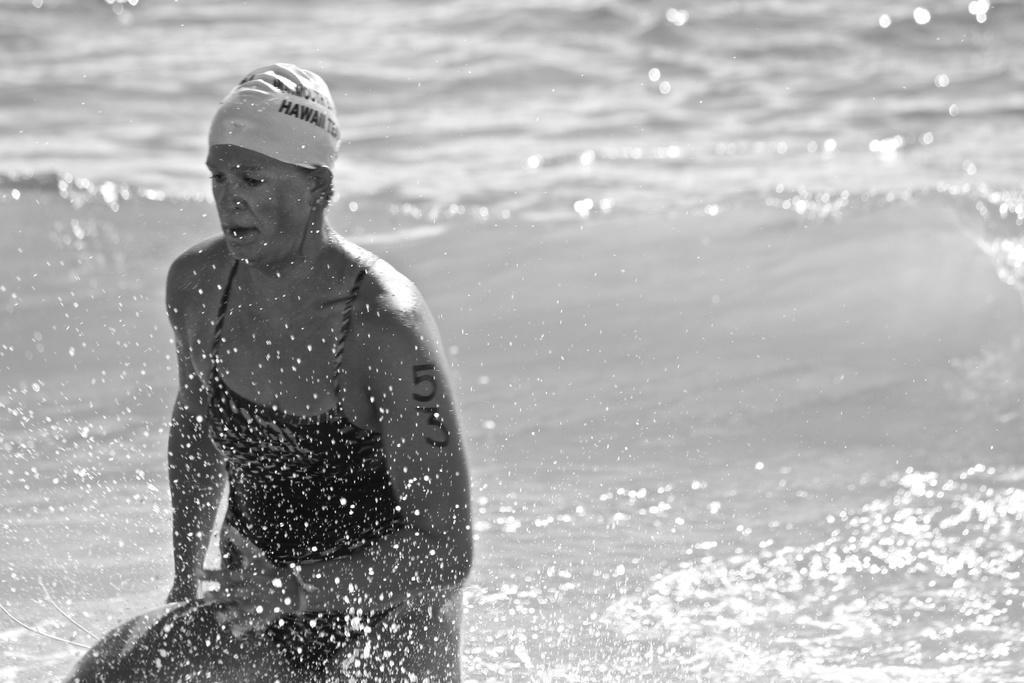Please provide a concise description of this image. In this image there is a woman towards the bottom of the image, she is wearing a cap, there is text on the cap, at the background of the image there is water. 